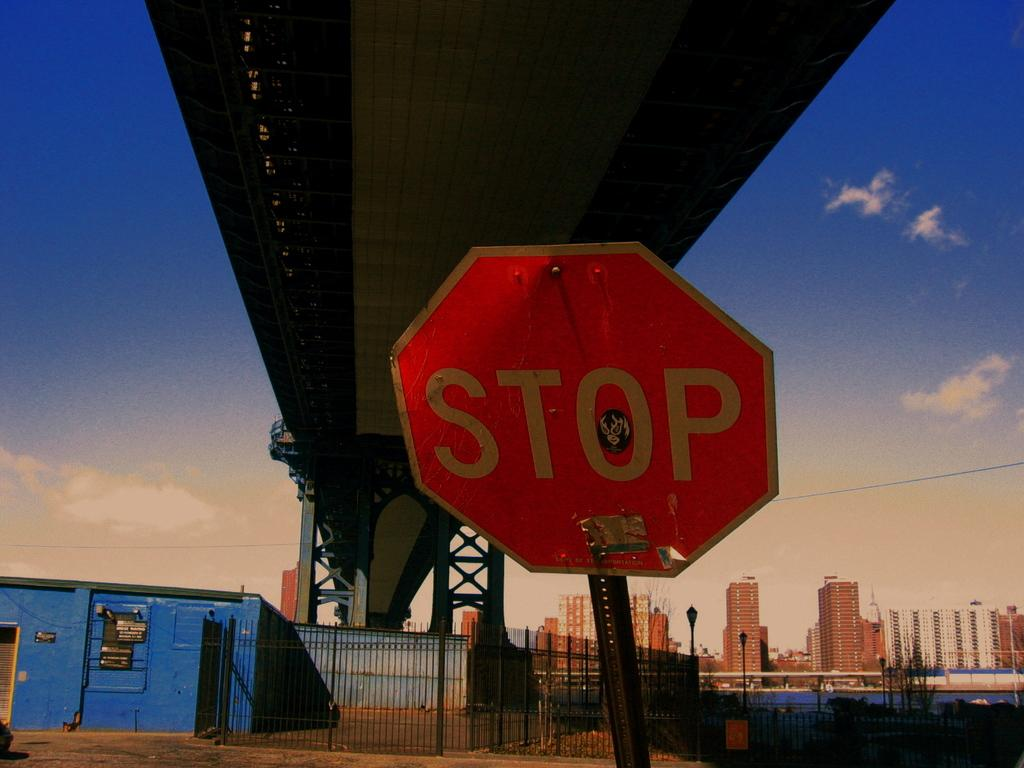<image>
Relay a brief, clear account of the picture shown. A RED OCTOGON STOP SIGN UNDER A BRIDGE 